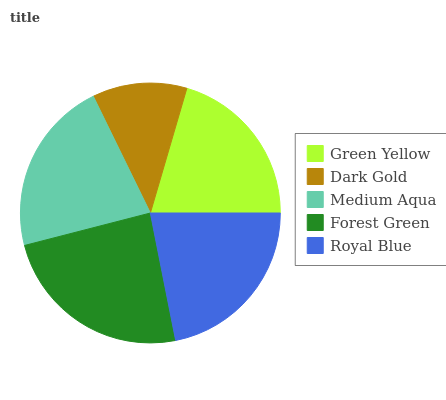Is Dark Gold the minimum?
Answer yes or no. Yes. Is Forest Green the maximum?
Answer yes or no. Yes. Is Medium Aqua the minimum?
Answer yes or no. No. Is Medium Aqua the maximum?
Answer yes or no. No. Is Medium Aqua greater than Dark Gold?
Answer yes or no. Yes. Is Dark Gold less than Medium Aqua?
Answer yes or no. Yes. Is Dark Gold greater than Medium Aqua?
Answer yes or no. No. Is Medium Aqua less than Dark Gold?
Answer yes or no. No. Is Medium Aqua the high median?
Answer yes or no. Yes. Is Medium Aqua the low median?
Answer yes or no. Yes. Is Royal Blue the high median?
Answer yes or no. No. Is Forest Green the low median?
Answer yes or no. No. 